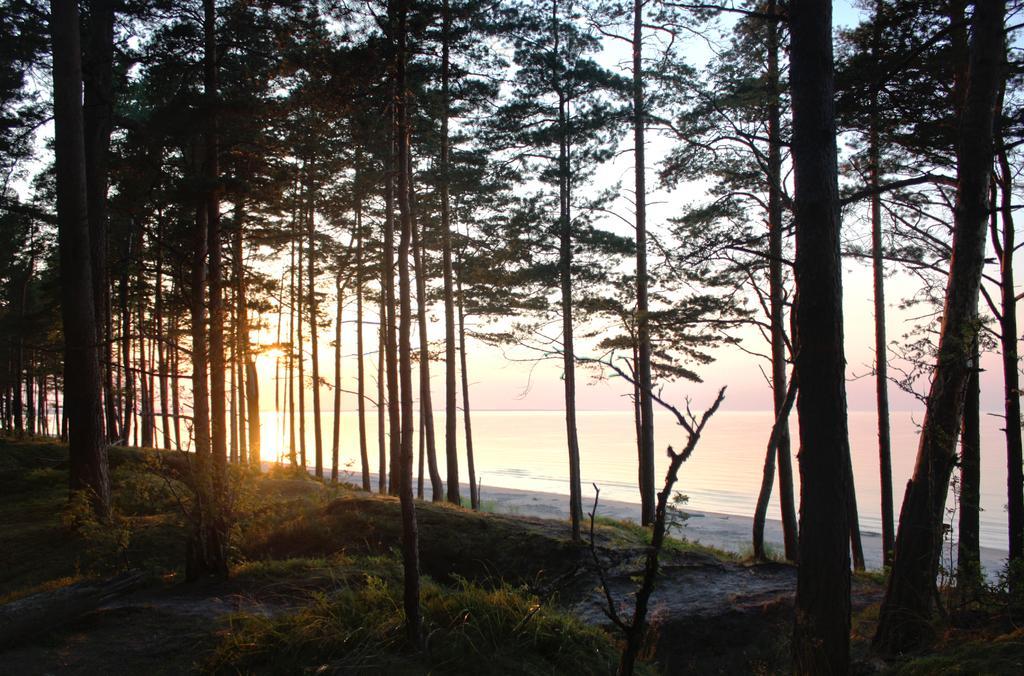Describe this image in one or two sentences. These are the trees with branches and leaves. I can see the grass. This looks like a seashore. Here is the sea. 